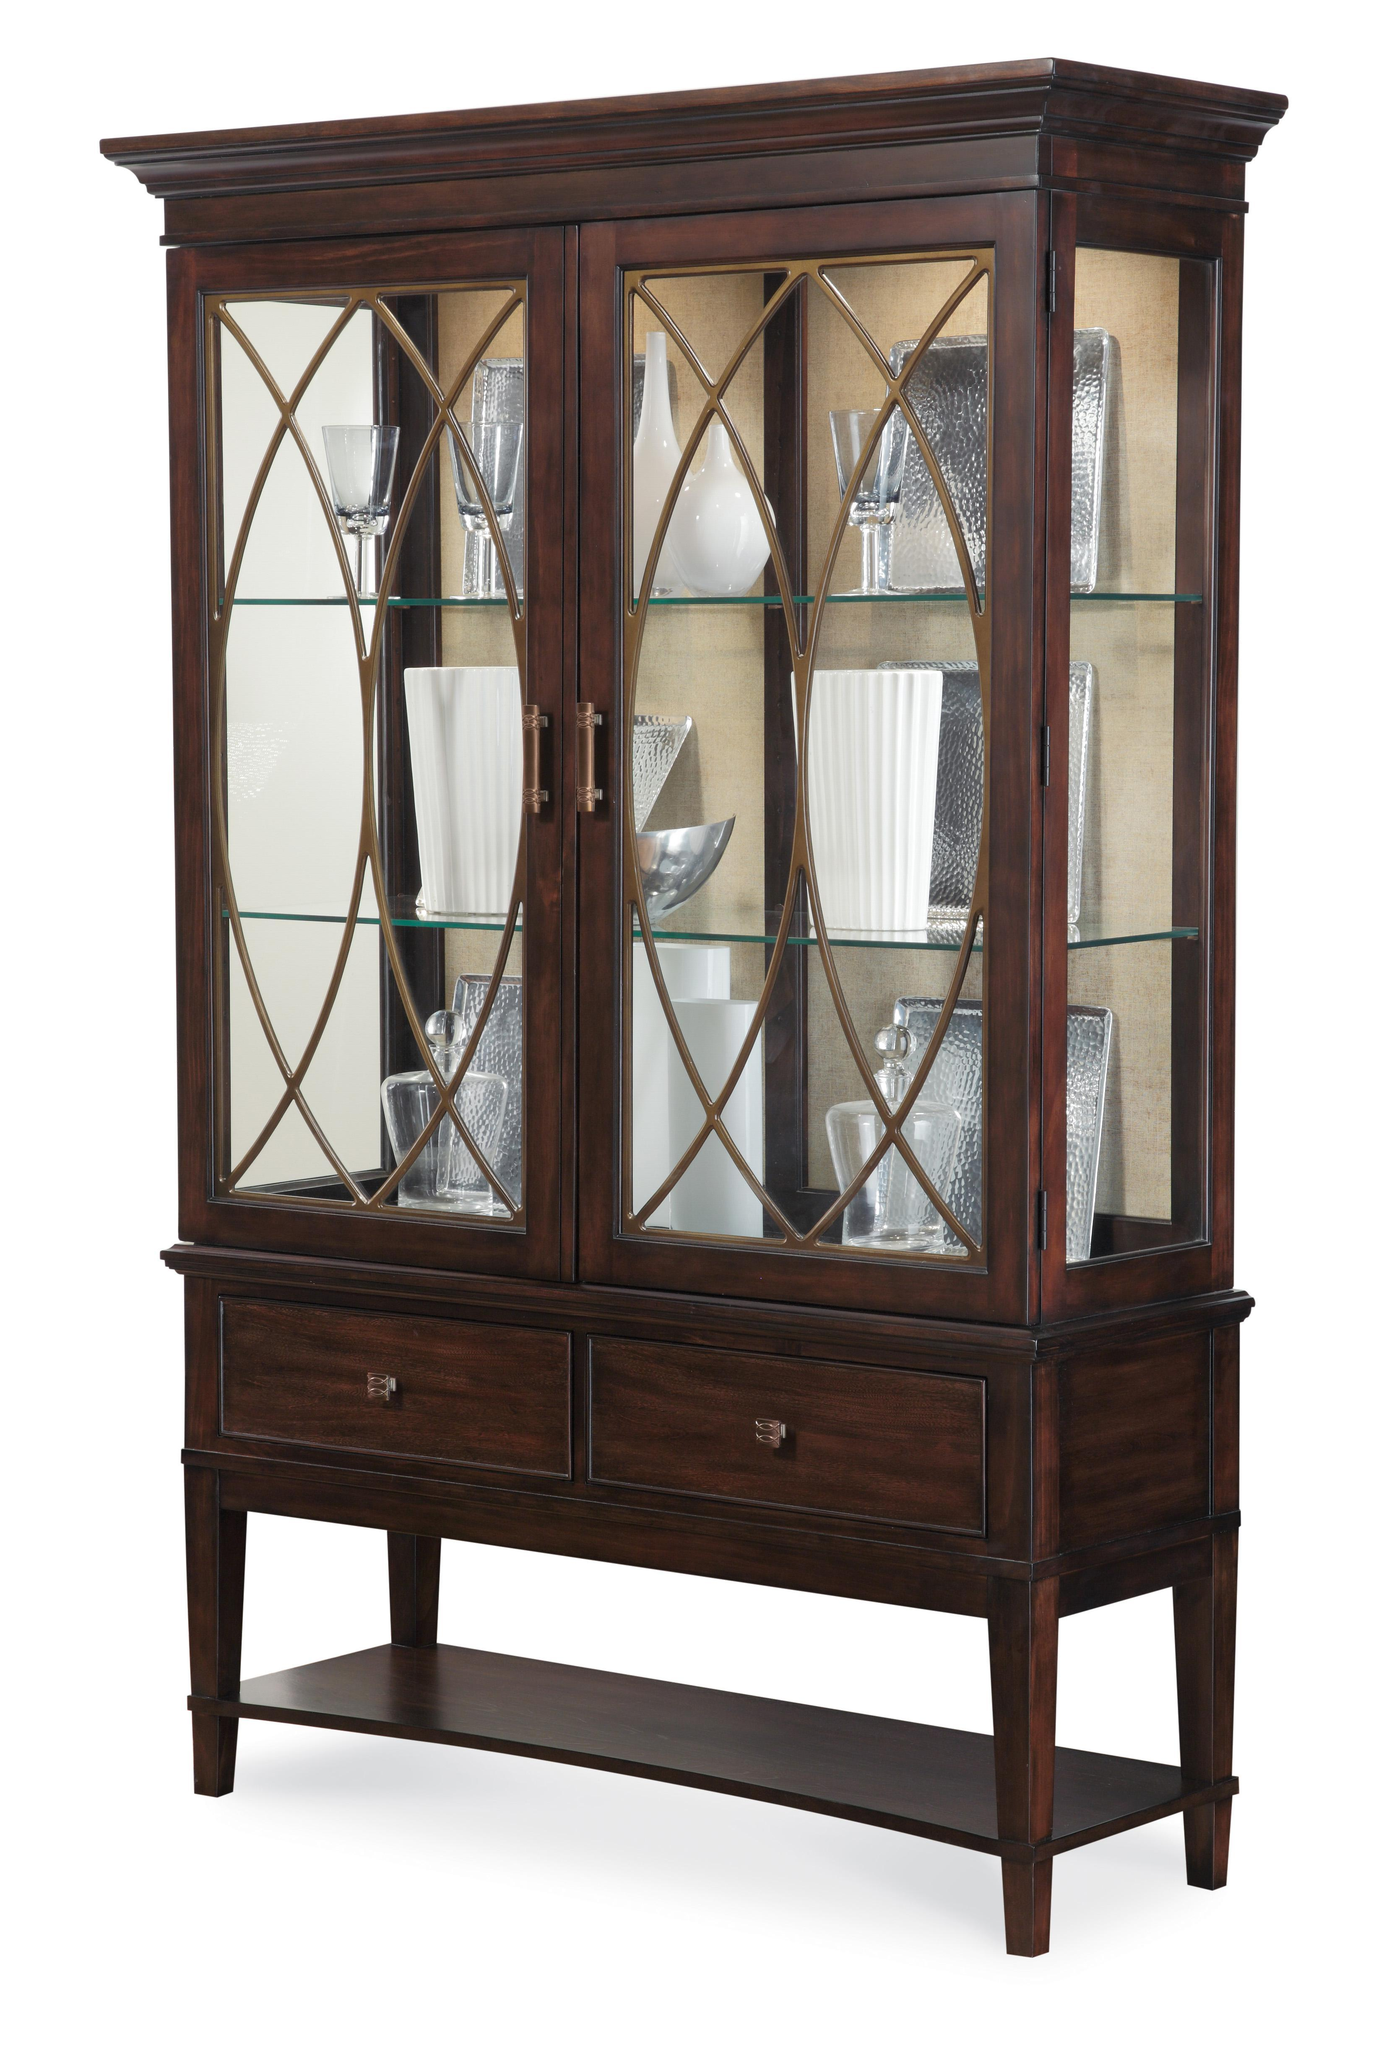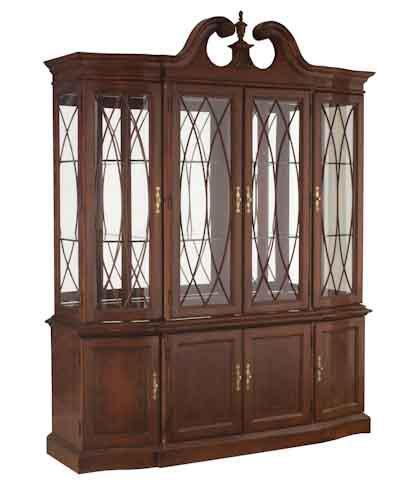The first image is the image on the left, the second image is the image on the right. For the images shown, is this caption "One of the cabinets is empty." true? Answer yes or no. Yes. 